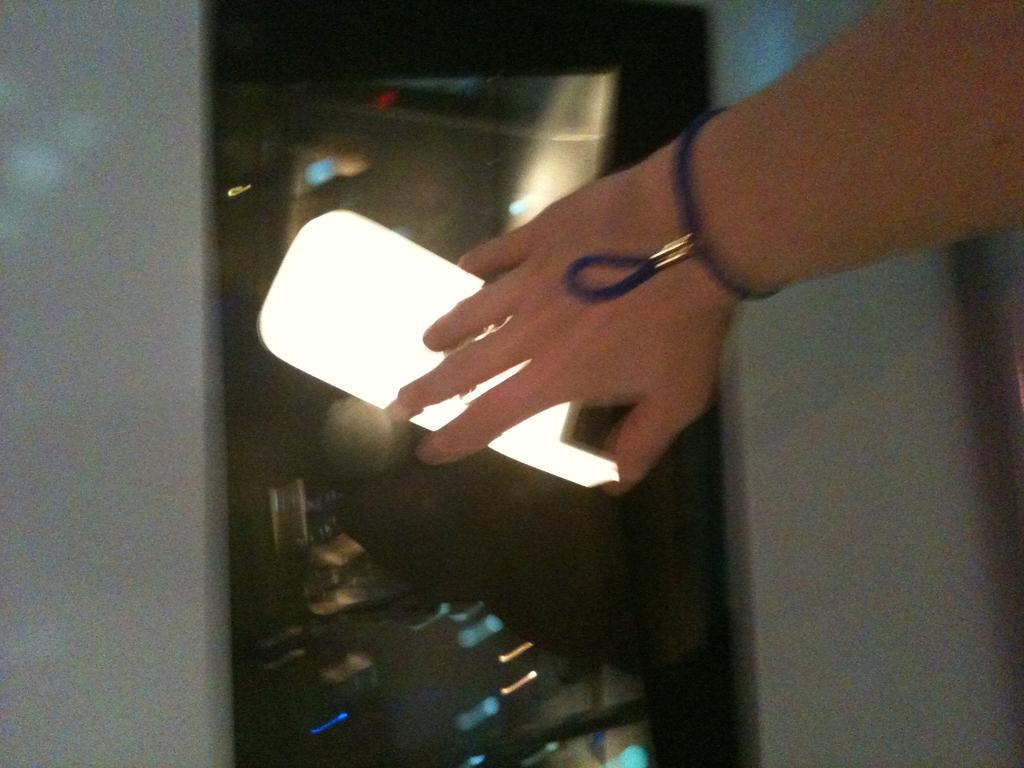What part of a person can be seen in the image? There is a hand of a person in the image. What else is visible in the image besides the hand? There are lights visible in the image. What type of jelly is being used to make peace in the image? There is no jelly or peace-making activity present in the image; it only features a hand and lights. 